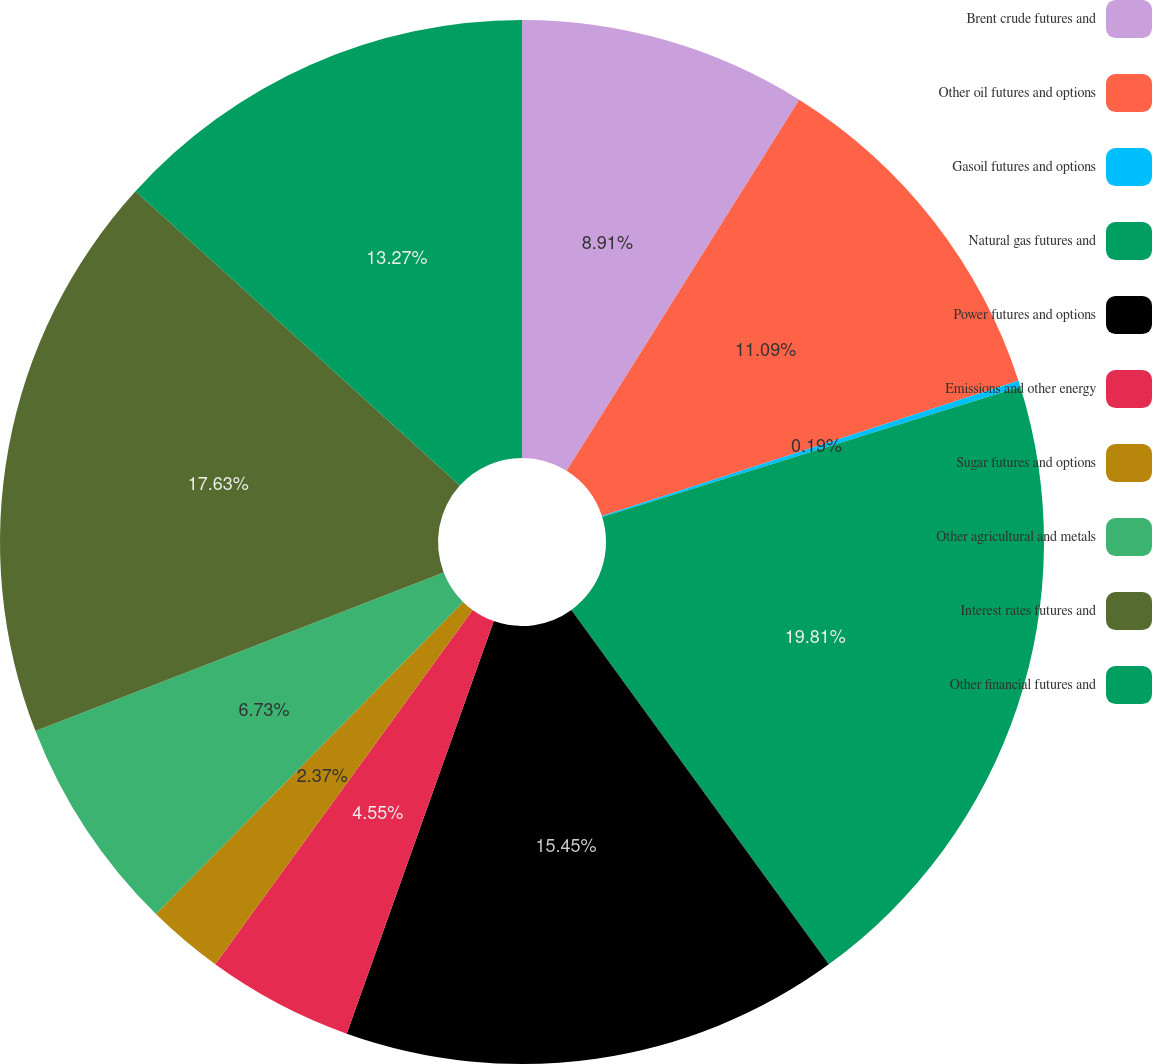Convert chart to OTSL. <chart><loc_0><loc_0><loc_500><loc_500><pie_chart><fcel>Brent crude futures and<fcel>Other oil futures and options<fcel>Gasoil futures and options<fcel>Natural gas futures and<fcel>Power futures and options<fcel>Emissions and other energy<fcel>Sugar futures and options<fcel>Other agricultural and metals<fcel>Interest rates futures and<fcel>Other financial futures and<nl><fcel>8.91%<fcel>11.09%<fcel>0.19%<fcel>19.81%<fcel>15.45%<fcel>4.55%<fcel>2.37%<fcel>6.73%<fcel>17.63%<fcel>13.27%<nl></chart> 